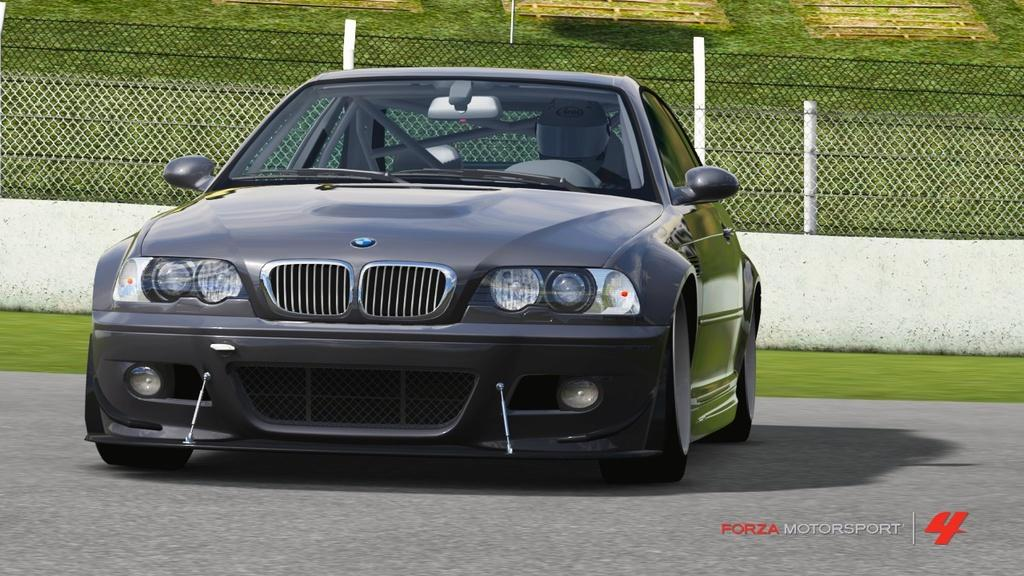What is located at the bottom of the image? There is a road at the bottom of the image. What can be seen in the foreground of the image? There is a vehicle in the foreground of the image. What type of vegetation is visible in the background of the image? There is grass in the background of the image. What structures can be seen in the background of the image? There is a wall and a mesh in the background of the image. Can you tell me what question the vehicle is asking in the image? There is no indication in the image that the vehicle is asking a question. Is the aunt present in the image? There is no mention of an aunt in the provided facts, and therefore we cannot determine if she is present in the image. 